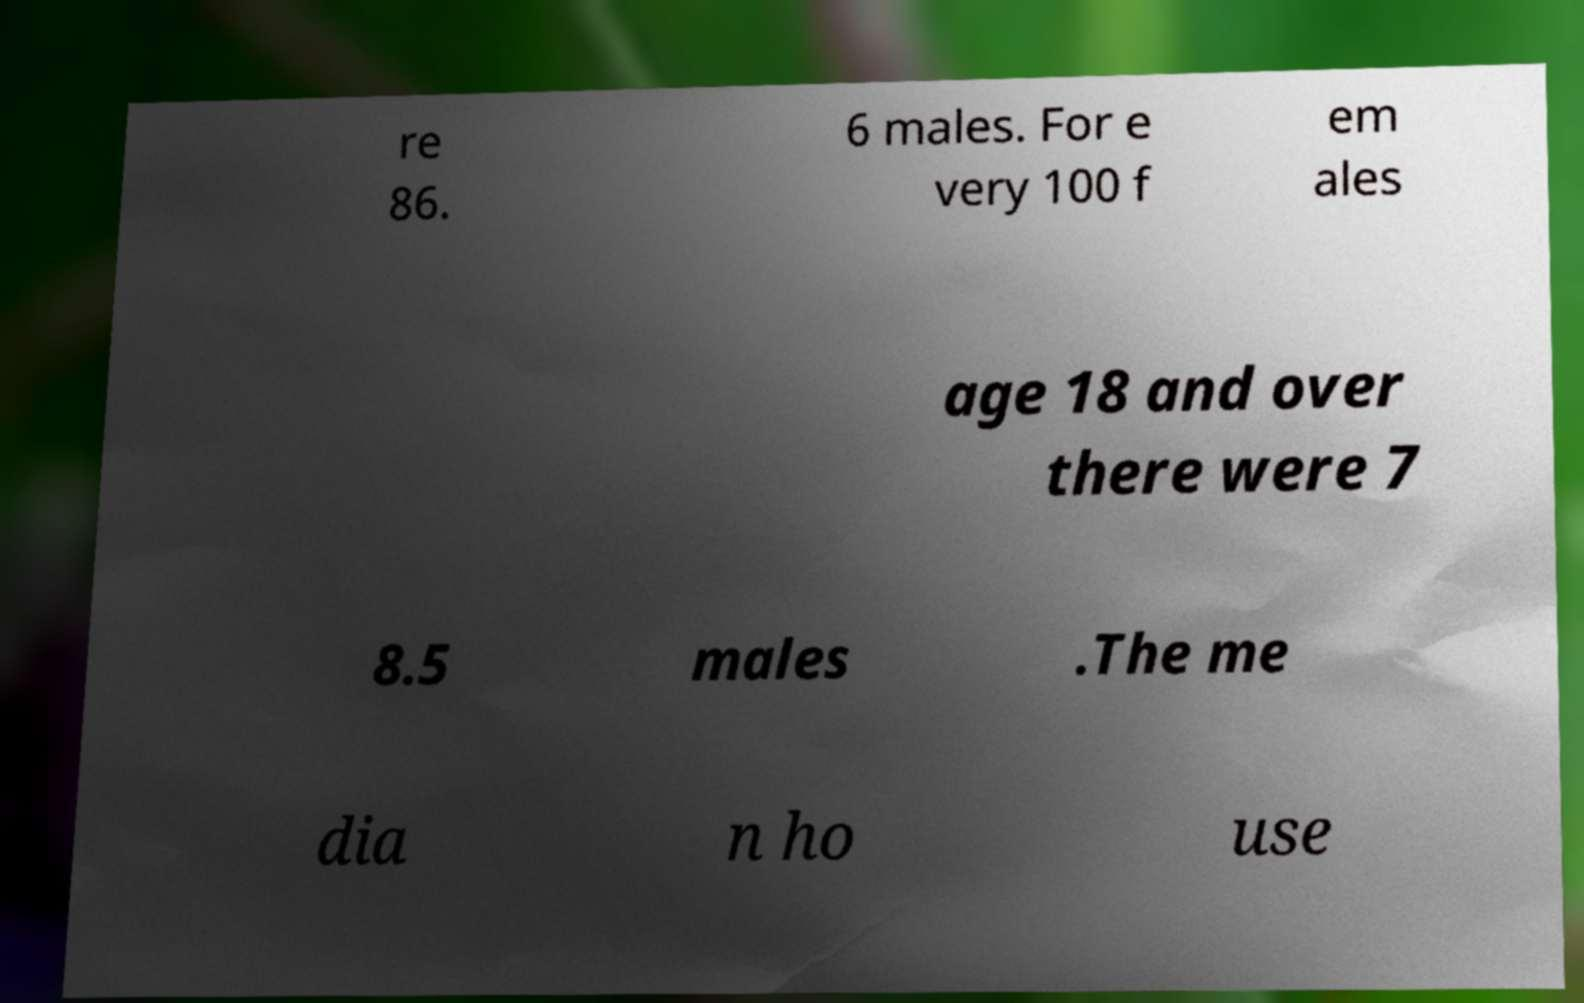There's text embedded in this image that I need extracted. Can you transcribe it verbatim? re 86. 6 males. For e very 100 f em ales age 18 and over there were 7 8.5 males .The me dia n ho use 